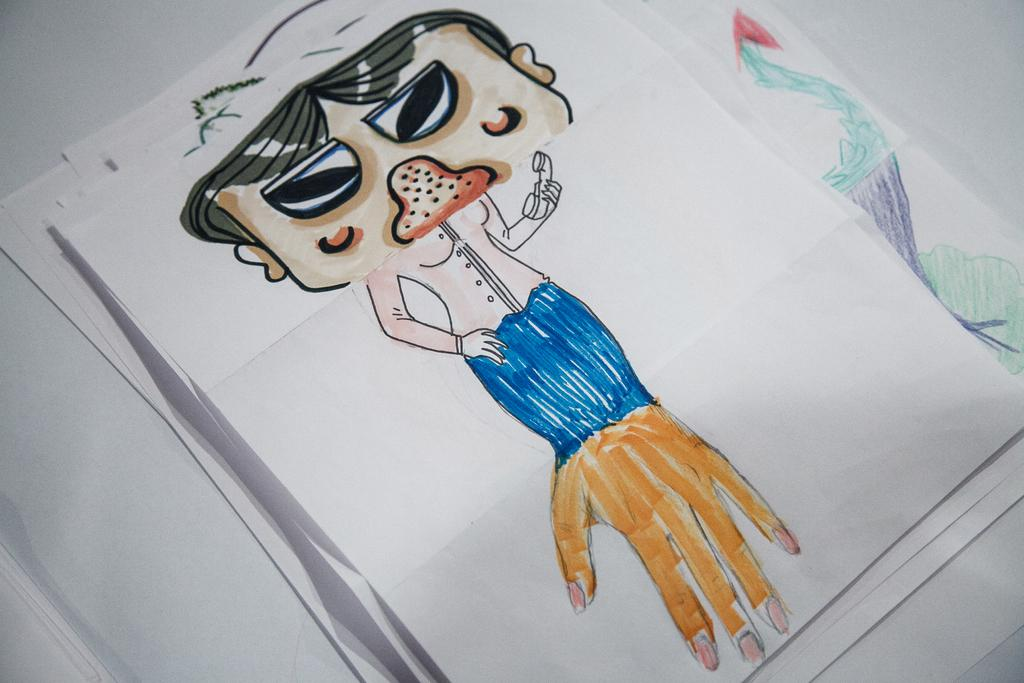What is depicted on the papers in the image? There are drawings on the papers. On what surface are the papers placed? The papers are placed on a white surface. What time of day is it in the image, and is there a dog jumping in the background? The time of day is not mentioned in the image, and there is no dog or jumping activity present. 